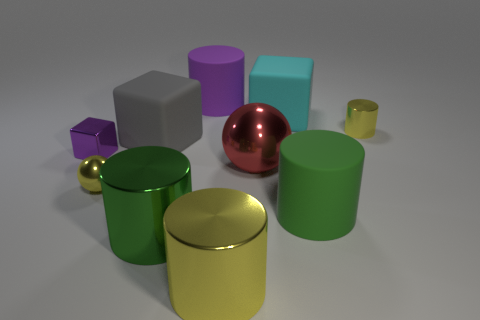What is the size of the purple block that is made of the same material as the large yellow thing?
Give a very brief answer. Small. There is a purple object that is behind the yellow cylinder behind the small purple object; what shape is it?
Give a very brief answer. Cylinder. How many green objects are either large matte cubes or rubber objects?
Your answer should be very brief. 1. There is a purple thing behind the small purple object that is to the left of the gray rubber object; is there a large sphere in front of it?
Offer a terse response. Yes. The big matte object that is the same color as the small shiny cube is what shape?
Make the answer very short. Cylinder. How many big things are either green rubber things or red balls?
Keep it short and to the point. 2. There is a big cyan rubber thing behind the big metallic sphere; does it have the same shape as the gray rubber thing?
Make the answer very short. Yes. Is the number of big gray cubes less than the number of small cyan matte cubes?
Make the answer very short. No. Are there any other things that are the same color as the tiny shiny block?
Your answer should be compact. Yes. There is a tiny yellow object that is behind the red metallic sphere; what shape is it?
Ensure brevity in your answer.  Cylinder. 